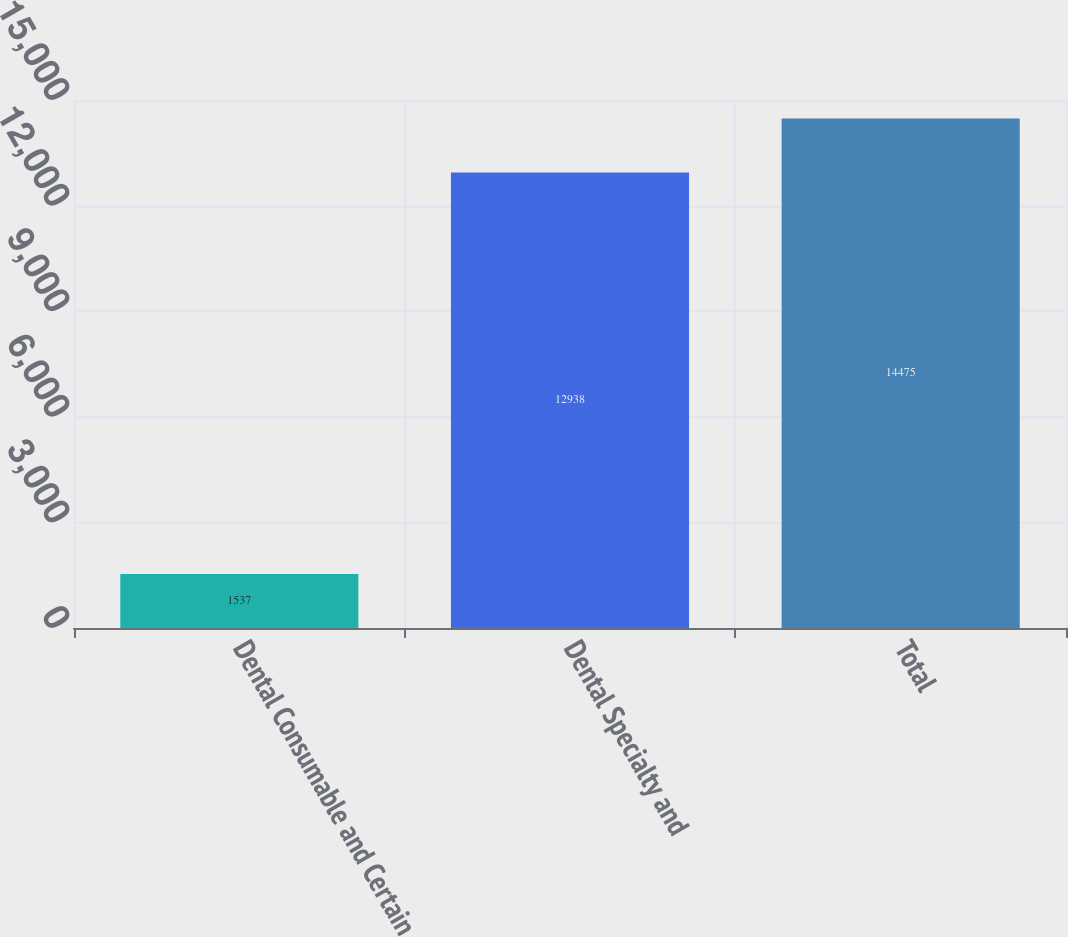Convert chart. <chart><loc_0><loc_0><loc_500><loc_500><bar_chart><fcel>Dental Consumable and Certain<fcel>Dental Specialty and<fcel>Total<nl><fcel>1537<fcel>12938<fcel>14475<nl></chart> 